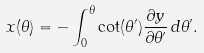Convert formula to latex. <formula><loc_0><loc_0><loc_500><loc_500>x ( \theta ) = - \int _ { 0 } ^ { \theta } \cot ( \theta ^ { \prime } ) \frac { \partial y } { \partial \theta ^ { \prime } } \, d \theta ^ { \prime } .</formula> 